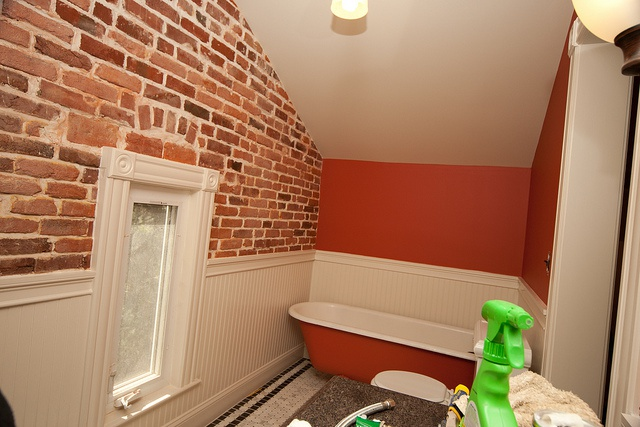Describe the objects in this image and their specific colors. I can see a toilet in gray, tan, and maroon tones in this image. 